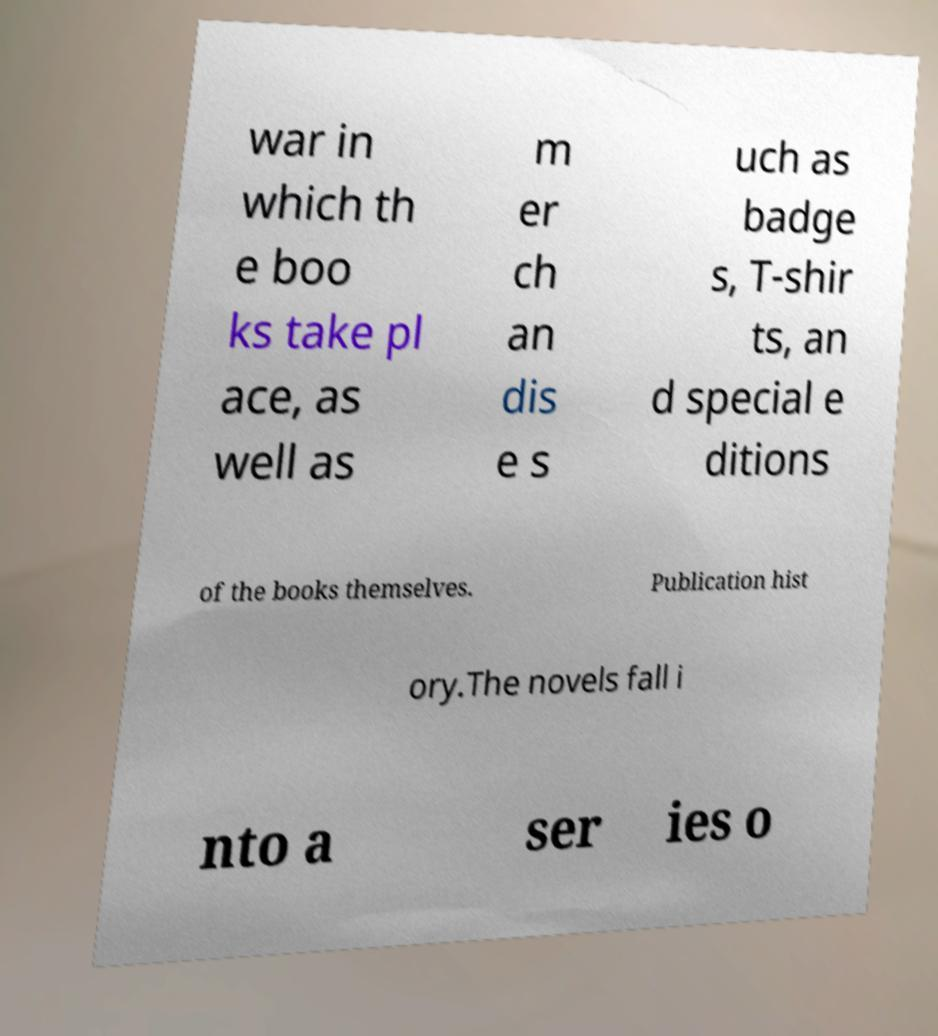There's text embedded in this image that I need extracted. Can you transcribe it verbatim? war in which th e boo ks take pl ace, as well as m er ch an dis e s uch as badge s, T-shir ts, an d special e ditions of the books themselves. Publication hist ory.The novels fall i nto a ser ies o 